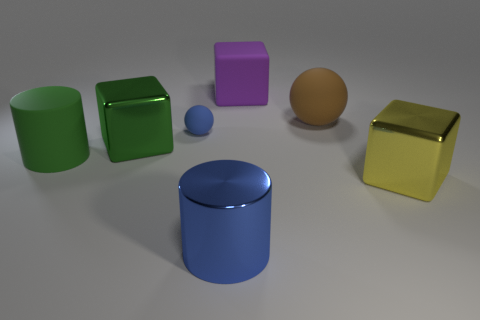Add 1 large brown matte cylinders. How many objects exist? 8 Subtract all balls. How many objects are left? 5 Add 4 purple cubes. How many purple cubes are left? 5 Add 7 tiny blue rubber spheres. How many tiny blue rubber spheres exist? 8 Subtract 0 green balls. How many objects are left? 7 Subtract all big purple metallic objects. Subtract all yellow metallic cubes. How many objects are left? 6 